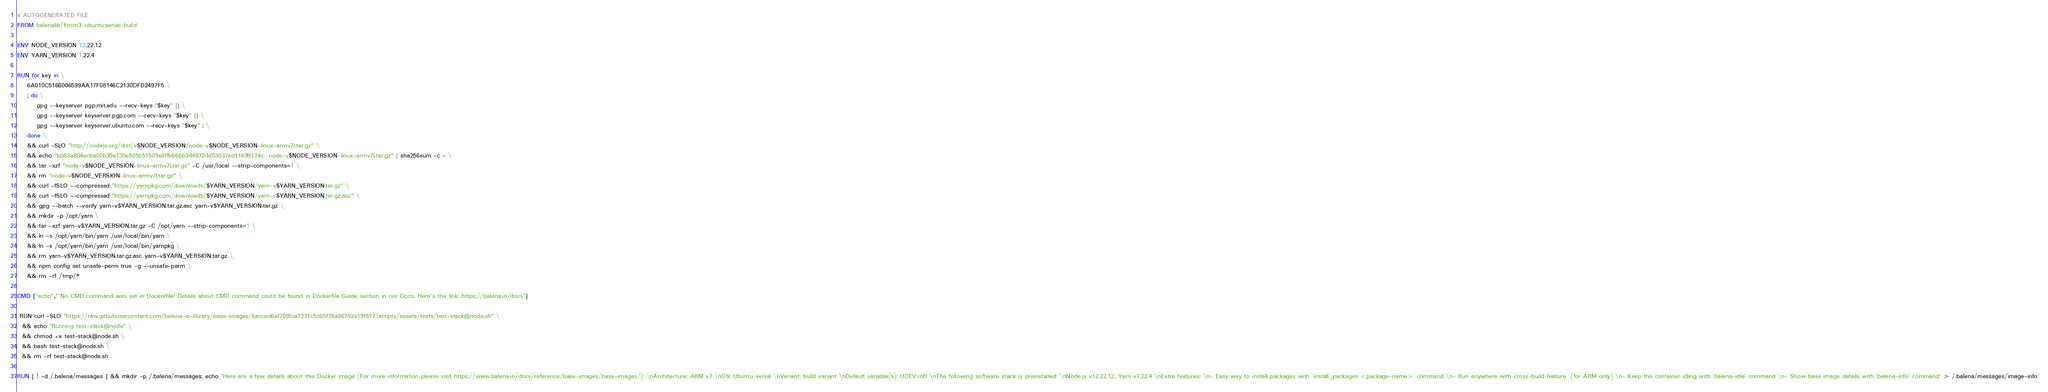<code> <loc_0><loc_0><loc_500><loc_500><_Dockerfile_># AUTOGENERATED FILE
FROM balenalib/fincm3-ubuntu:xenial-build

ENV NODE_VERSION 12.22.12
ENV YARN_VERSION 1.22.4

RUN for key in \
	6A010C5166006599AA17F08146C2130DFD2497F5 \
	; do \
		gpg --keyserver pgp.mit.edu --recv-keys "$key" || \
		gpg --keyserver keyserver.pgp.com --recv-keys "$key" || \
		gpg --keyserver keyserver.ubuntu.com --recv-keys "$key" ; \
	done \
	&& curl -SLO "http://nodejs.org/dist/v$NODE_VERSION/node-v$NODE_VERSION-linux-armv7l.tar.gz" \
	&& echo "bb68e804ecba00b30a135e505b51509e8ffb666b3d4872dd53037ad11699174c  node-v$NODE_VERSION-linux-armv7l.tar.gz" | sha256sum -c - \
	&& tar -xzf "node-v$NODE_VERSION-linux-armv7l.tar.gz" -C /usr/local --strip-components=1 \
	&& rm "node-v$NODE_VERSION-linux-armv7l.tar.gz" \
	&& curl -fSLO --compressed "https://yarnpkg.com/downloads/$YARN_VERSION/yarn-v$YARN_VERSION.tar.gz" \
	&& curl -fSLO --compressed "https://yarnpkg.com/downloads/$YARN_VERSION/yarn-v$YARN_VERSION.tar.gz.asc" \
	&& gpg --batch --verify yarn-v$YARN_VERSION.tar.gz.asc yarn-v$YARN_VERSION.tar.gz \
	&& mkdir -p /opt/yarn \
	&& tar -xzf yarn-v$YARN_VERSION.tar.gz -C /opt/yarn --strip-components=1 \
	&& ln -s /opt/yarn/bin/yarn /usr/local/bin/yarn \
	&& ln -s /opt/yarn/bin/yarn /usr/local/bin/yarnpkg \
	&& rm yarn-v$YARN_VERSION.tar.gz.asc yarn-v$YARN_VERSION.tar.gz \
	&& npm config set unsafe-perm true -g --unsafe-perm \
	&& rm -rf /tmp/*

CMD ["echo","'No CMD command was set in Dockerfile! Details about CMD command could be found in Dockerfile Guide section in our Docs. Here's the link: https://balena.io/docs"]

 RUN curl -SLO "https://raw.githubusercontent.com/balena-io-library/base-images/8accad6af708fca7271c5c65f18a86782e19f877/scripts/assets/tests/test-stack@node.sh" \
  && echo "Running test-stack@node" \
  && chmod +x test-stack@node.sh \
  && bash test-stack@node.sh \
  && rm -rf test-stack@node.sh 

RUN [ ! -d /.balena/messages ] && mkdir -p /.balena/messages; echo 'Here are a few details about this Docker image (For more information please visit https://www.balena.io/docs/reference/base-images/base-images/): \nArchitecture: ARM v7 \nOS: Ubuntu xenial \nVariant: build variant \nDefault variable(s): UDEV=off \nThe following software stack is preinstalled: \nNode.js v12.22.12, Yarn v1.22.4 \nExtra features: \n- Easy way to install packages with `install_packages <package-name>` command \n- Run anywhere with cross-build feature  (for ARM only) \n- Keep the container idling with `balena-idle` command \n- Show base image details with `balena-info` command' > /.balena/messages/image-info</code> 